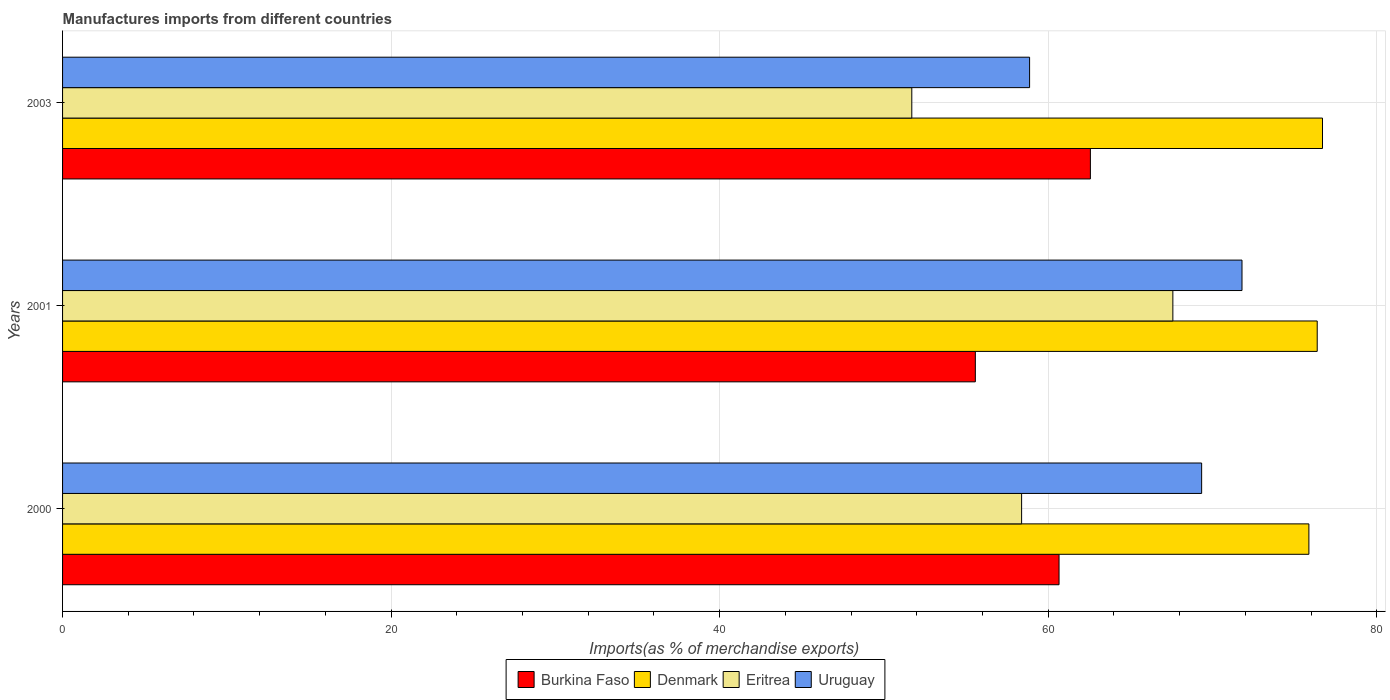How many different coloured bars are there?
Provide a succinct answer. 4. Are the number of bars on each tick of the Y-axis equal?
Ensure brevity in your answer.  Yes. How many bars are there on the 1st tick from the top?
Offer a very short reply. 4. What is the label of the 3rd group of bars from the top?
Your answer should be very brief. 2000. In how many cases, is the number of bars for a given year not equal to the number of legend labels?
Your answer should be very brief. 0. What is the percentage of imports to different countries in Uruguay in 2001?
Ensure brevity in your answer.  71.8. Across all years, what is the maximum percentage of imports to different countries in Uruguay?
Your answer should be very brief. 71.8. Across all years, what is the minimum percentage of imports to different countries in Denmark?
Provide a succinct answer. 75.87. In which year was the percentage of imports to different countries in Denmark minimum?
Your response must be concise. 2000. What is the total percentage of imports to different countries in Eritrea in the graph?
Give a very brief answer. 177.67. What is the difference between the percentage of imports to different countries in Denmark in 2000 and that in 2003?
Ensure brevity in your answer.  -0.83. What is the difference between the percentage of imports to different countries in Burkina Faso in 2000 and the percentage of imports to different countries in Denmark in 2001?
Offer a very short reply. -15.72. What is the average percentage of imports to different countries in Eritrea per year?
Offer a very short reply. 59.22. In the year 2001, what is the difference between the percentage of imports to different countries in Denmark and percentage of imports to different countries in Uruguay?
Ensure brevity in your answer.  4.58. What is the ratio of the percentage of imports to different countries in Uruguay in 2001 to that in 2003?
Your response must be concise. 1.22. Is the percentage of imports to different countries in Eritrea in 2000 less than that in 2001?
Offer a very short reply. Yes. What is the difference between the highest and the second highest percentage of imports to different countries in Denmark?
Give a very brief answer. 0.32. What is the difference between the highest and the lowest percentage of imports to different countries in Uruguay?
Provide a succinct answer. 12.93. Is the sum of the percentage of imports to different countries in Burkina Faso in 2001 and 2003 greater than the maximum percentage of imports to different countries in Uruguay across all years?
Provide a succinct answer. Yes. Is it the case that in every year, the sum of the percentage of imports to different countries in Denmark and percentage of imports to different countries in Eritrea is greater than the sum of percentage of imports to different countries in Uruguay and percentage of imports to different countries in Burkina Faso?
Ensure brevity in your answer.  No. What does the 2nd bar from the bottom in 2003 represents?
Offer a terse response. Denmark. Is it the case that in every year, the sum of the percentage of imports to different countries in Burkina Faso and percentage of imports to different countries in Uruguay is greater than the percentage of imports to different countries in Denmark?
Your response must be concise. Yes. What is the difference between two consecutive major ticks on the X-axis?
Provide a short and direct response. 20. Does the graph contain grids?
Offer a terse response. Yes. Where does the legend appear in the graph?
Offer a terse response. Bottom center. How many legend labels are there?
Offer a terse response. 4. How are the legend labels stacked?
Your answer should be compact. Horizontal. What is the title of the graph?
Provide a short and direct response. Manufactures imports from different countries. Does "Austria" appear as one of the legend labels in the graph?
Your answer should be compact. No. What is the label or title of the X-axis?
Provide a succinct answer. Imports(as % of merchandise exports). What is the Imports(as % of merchandise exports) in Burkina Faso in 2000?
Your answer should be compact. 60.66. What is the Imports(as % of merchandise exports) in Denmark in 2000?
Your answer should be very brief. 75.87. What is the Imports(as % of merchandise exports) of Eritrea in 2000?
Your answer should be compact. 58.38. What is the Imports(as % of merchandise exports) in Uruguay in 2000?
Your answer should be compact. 69.34. What is the Imports(as % of merchandise exports) of Burkina Faso in 2001?
Provide a succinct answer. 55.56. What is the Imports(as % of merchandise exports) in Denmark in 2001?
Your response must be concise. 76.38. What is the Imports(as % of merchandise exports) in Eritrea in 2001?
Offer a terse response. 67.59. What is the Imports(as % of merchandise exports) of Uruguay in 2001?
Keep it short and to the point. 71.8. What is the Imports(as % of merchandise exports) of Burkina Faso in 2003?
Keep it short and to the point. 62.57. What is the Imports(as % of merchandise exports) in Denmark in 2003?
Make the answer very short. 76.7. What is the Imports(as % of merchandise exports) of Eritrea in 2003?
Offer a terse response. 51.7. What is the Imports(as % of merchandise exports) in Uruguay in 2003?
Ensure brevity in your answer.  58.87. Across all years, what is the maximum Imports(as % of merchandise exports) in Burkina Faso?
Make the answer very short. 62.57. Across all years, what is the maximum Imports(as % of merchandise exports) in Denmark?
Make the answer very short. 76.7. Across all years, what is the maximum Imports(as % of merchandise exports) of Eritrea?
Your answer should be very brief. 67.59. Across all years, what is the maximum Imports(as % of merchandise exports) of Uruguay?
Make the answer very short. 71.8. Across all years, what is the minimum Imports(as % of merchandise exports) in Burkina Faso?
Offer a terse response. 55.56. Across all years, what is the minimum Imports(as % of merchandise exports) of Denmark?
Offer a very short reply. 75.87. Across all years, what is the minimum Imports(as % of merchandise exports) of Eritrea?
Ensure brevity in your answer.  51.7. Across all years, what is the minimum Imports(as % of merchandise exports) in Uruguay?
Offer a terse response. 58.87. What is the total Imports(as % of merchandise exports) of Burkina Faso in the graph?
Your response must be concise. 178.79. What is the total Imports(as % of merchandise exports) of Denmark in the graph?
Offer a terse response. 228.94. What is the total Imports(as % of merchandise exports) of Eritrea in the graph?
Keep it short and to the point. 177.67. What is the total Imports(as % of merchandise exports) of Uruguay in the graph?
Make the answer very short. 200. What is the difference between the Imports(as % of merchandise exports) of Burkina Faso in 2000 and that in 2001?
Provide a succinct answer. 5.1. What is the difference between the Imports(as % of merchandise exports) in Denmark in 2000 and that in 2001?
Ensure brevity in your answer.  -0.51. What is the difference between the Imports(as % of merchandise exports) in Eritrea in 2000 and that in 2001?
Your response must be concise. -9.21. What is the difference between the Imports(as % of merchandise exports) of Uruguay in 2000 and that in 2001?
Your answer should be very brief. -2.46. What is the difference between the Imports(as % of merchandise exports) of Burkina Faso in 2000 and that in 2003?
Make the answer very short. -1.91. What is the difference between the Imports(as % of merchandise exports) of Denmark in 2000 and that in 2003?
Offer a very short reply. -0.83. What is the difference between the Imports(as % of merchandise exports) of Eritrea in 2000 and that in 2003?
Provide a short and direct response. 6.68. What is the difference between the Imports(as % of merchandise exports) in Uruguay in 2000 and that in 2003?
Ensure brevity in your answer.  10.47. What is the difference between the Imports(as % of merchandise exports) of Burkina Faso in 2001 and that in 2003?
Offer a terse response. -7. What is the difference between the Imports(as % of merchandise exports) of Denmark in 2001 and that in 2003?
Your answer should be very brief. -0.32. What is the difference between the Imports(as % of merchandise exports) of Eritrea in 2001 and that in 2003?
Offer a terse response. 15.89. What is the difference between the Imports(as % of merchandise exports) in Uruguay in 2001 and that in 2003?
Keep it short and to the point. 12.93. What is the difference between the Imports(as % of merchandise exports) of Burkina Faso in 2000 and the Imports(as % of merchandise exports) of Denmark in 2001?
Your response must be concise. -15.72. What is the difference between the Imports(as % of merchandise exports) of Burkina Faso in 2000 and the Imports(as % of merchandise exports) of Eritrea in 2001?
Make the answer very short. -6.93. What is the difference between the Imports(as % of merchandise exports) in Burkina Faso in 2000 and the Imports(as % of merchandise exports) in Uruguay in 2001?
Your answer should be very brief. -11.14. What is the difference between the Imports(as % of merchandise exports) of Denmark in 2000 and the Imports(as % of merchandise exports) of Eritrea in 2001?
Your response must be concise. 8.28. What is the difference between the Imports(as % of merchandise exports) in Denmark in 2000 and the Imports(as % of merchandise exports) in Uruguay in 2001?
Your answer should be very brief. 4.07. What is the difference between the Imports(as % of merchandise exports) in Eritrea in 2000 and the Imports(as % of merchandise exports) in Uruguay in 2001?
Make the answer very short. -13.42. What is the difference between the Imports(as % of merchandise exports) of Burkina Faso in 2000 and the Imports(as % of merchandise exports) of Denmark in 2003?
Offer a very short reply. -16.04. What is the difference between the Imports(as % of merchandise exports) of Burkina Faso in 2000 and the Imports(as % of merchandise exports) of Eritrea in 2003?
Provide a short and direct response. 8.96. What is the difference between the Imports(as % of merchandise exports) of Burkina Faso in 2000 and the Imports(as % of merchandise exports) of Uruguay in 2003?
Make the answer very short. 1.79. What is the difference between the Imports(as % of merchandise exports) in Denmark in 2000 and the Imports(as % of merchandise exports) in Eritrea in 2003?
Ensure brevity in your answer.  24.17. What is the difference between the Imports(as % of merchandise exports) of Denmark in 2000 and the Imports(as % of merchandise exports) of Uruguay in 2003?
Give a very brief answer. 17. What is the difference between the Imports(as % of merchandise exports) of Eritrea in 2000 and the Imports(as % of merchandise exports) of Uruguay in 2003?
Provide a short and direct response. -0.49. What is the difference between the Imports(as % of merchandise exports) in Burkina Faso in 2001 and the Imports(as % of merchandise exports) in Denmark in 2003?
Give a very brief answer. -21.13. What is the difference between the Imports(as % of merchandise exports) in Burkina Faso in 2001 and the Imports(as % of merchandise exports) in Eritrea in 2003?
Give a very brief answer. 3.87. What is the difference between the Imports(as % of merchandise exports) of Burkina Faso in 2001 and the Imports(as % of merchandise exports) of Uruguay in 2003?
Ensure brevity in your answer.  -3.3. What is the difference between the Imports(as % of merchandise exports) in Denmark in 2001 and the Imports(as % of merchandise exports) in Eritrea in 2003?
Provide a succinct answer. 24.68. What is the difference between the Imports(as % of merchandise exports) of Denmark in 2001 and the Imports(as % of merchandise exports) of Uruguay in 2003?
Make the answer very short. 17.51. What is the difference between the Imports(as % of merchandise exports) of Eritrea in 2001 and the Imports(as % of merchandise exports) of Uruguay in 2003?
Ensure brevity in your answer.  8.72. What is the average Imports(as % of merchandise exports) of Burkina Faso per year?
Your response must be concise. 59.6. What is the average Imports(as % of merchandise exports) in Denmark per year?
Provide a succinct answer. 76.31. What is the average Imports(as % of merchandise exports) of Eritrea per year?
Keep it short and to the point. 59.22. What is the average Imports(as % of merchandise exports) in Uruguay per year?
Your response must be concise. 66.67. In the year 2000, what is the difference between the Imports(as % of merchandise exports) in Burkina Faso and Imports(as % of merchandise exports) in Denmark?
Your response must be concise. -15.21. In the year 2000, what is the difference between the Imports(as % of merchandise exports) in Burkina Faso and Imports(as % of merchandise exports) in Eritrea?
Provide a short and direct response. 2.28. In the year 2000, what is the difference between the Imports(as % of merchandise exports) in Burkina Faso and Imports(as % of merchandise exports) in Uruguay?
Your response must be concise. -8.68. In the year 2000, what is the difference between the Imports(as % of merchandise exports) in Denmark and Imports(as % of merchandise exports) in Eritrea?
Keep it short and to the point. 17.49. In the year 2000, what is the difference between the Imports(as % of merchandise exports) of Denmark and Imports(as % of merchandise exports) of Uruguay?
Your answer should be very brief. 6.53. In the year 2000, what is the difference between the Imports(as % of merchandise exports) in Eritrea and Imports(as % of merchandise exports) in Uruguay?
Provide a succinct answer. -10.96. In the year 2001, what is the difference between the Imports(as % of merchandise exports) in Burkina Faso and Imports(as % of merchandise exports) in Denmark?
Make the answer very short. -20.81. In the year 2001, what is the difference between the Imports(as % of merchandise exports) in Burkina Faso and Imports(as % of merchandise exports) in Eritrea?
Offer a very short reply. -12.02. In the year 2001, what is the difference between the Imports(as % of merchandise exports) in Burkina Faso and Imports(as % of merchandise exports) in Uruguay?
Make the answer very short. -16.23. In the year 2001, what is the difference between the Imports(as % of merchandise exports) in Denmark and Imports(as % of merchandise exports) in Eritrea?
Ensure brevity in your answer.  8.79. In the year 2001, what is the difference between the Imports(as % of merchandise exports) of Denmark and Imports(as % of merchandise exports) of Uruguay?
Make the answer very short. 4.58. In the year 2001, what is the difference between the Imports(as % of merchandise exports) in Eritrea and Imports(as % of merchandise exports) in Uruguay?
Give a very brief answer. -4.21. In the year 2003, what is the difference between the Imports(as % of merchandise exports) of Burkina Faso and Imports(as % of merchandise exports) of Denmark?
Make the answer very short. -14.13. In the year 2003, what is the difference between the Imports(as % of merchandise exports) in Burkina Faso and Imports(as % of merchandise exports) in Eritrea?
Offer a very short reply. 10.87. In the year 2003, what is the difference between the Imports(as % of merchandise exports) in Burkina Faso and Imports(as % of merchandise exports) in Uruguay?
Your answer should be very brief. 3.7. In the year 2003, what is the difference between the Imports(as % of merchandise exports) of Denmark and Imports(as % of merchandise exports) of Eritrea?
Offer a very short reply. 25. In the year 2003, what is the difference between the Imports(as % of merchandise exports) of Denmark and Imports(as % of merchandise exports) of Uruguay?
Your response must be concise. 17.83. In the year 2003, what is the difference between the Imports(as % of merchandise exports) in Eritrea and Imports(as % of merchandise exports) in Uruguay?
Your answer should be very brief. -7.17. What is the ratio of the Imports(as % of merchandise exports) in Burkina Faso in 2000 to that in 2001?
Provide a short and direct response. 1.09. What is the ratio of the Imports(as % of merchandise exports) in Denmark in 2000 to that in 2001?
Offer a very short reply. 0.99. What is the ratio of the Imports(as % of merchandise exports) in Eritrea in 2000 to that in 2001?
Your answer should be compact. 0.86. What is the ratio of the Imports(as % of merchandise exports) of Uruguay in 2000 to that in 2001?
Your answer should be very brief. 0.97. What is the ratio of the Imports(as % of merchandise exports) in Burkina Faso in 2000 to that in 2003?
Your response must be concise. 0.97. What is the ratio of the Imports(as % of merchandise exports) in Denmark in 2000 to that in 2003?
Make the answer very short. 0.99. What is the ratio of the Imports(as % of merchandise exports) of Eritrea in 2000 to that in 2003?
Offer a very short reply. 1.13. What is the ratio of the Imports(as % of merchandise exports) in Uruguay in 2000 to that in 2003?
Your response must be concise. 1.18. What is the ratio of the Imports(as % of merchandise exports) in Burkina Faso in 2001 to that in 2003?
Your answer should be compact. 0.89. What is the ratio of the Imports(as % of merchandise exports) of Denmark in 2001 to that in 2003?
Offer a terse response. 1. What is the ratio of the Imports(as % of merchandise exports) in Eritrea in 2001 to that in 2003?
Provide a succinct answer. 1.31. What is the ratio of the Imports(as % of merchandise exports) in Uruguay in 2001 to that in 2003?
Ensure brevity in your answer.  1.22. What is the difference between the highest and the second highest Imports(as % of merchandise exports) in Burkina Faso?
Your response must be concise. 1.91. What is the difference between the highest and the second highest Imports(as % of merchandise exports) in Denmark?
Offer a very short reply. 0.32. What is the difference between the highest and the second highest Imports(as % of merchandise exports) of Eritrea?
Make the answer very short. 9.21. What is the difference between the highest and the second highest Imports(as % of merchandise exports) in Uruguay?
Offer a very short reply. 2.46. What is the difference between the highest and the lowest Imports(as % of merchandise exports) of Burkina Faso?
Your answer should be very brief. 7. What is the difference between the highest and the lowest Imports(as % of merchandise exports) of Denmark?
Offer a terse response. 0.83. What is the difference between the highest and the lowest Imports(as % of merchandise exports) in Eritrea?
Offer a terse response. 15.89. What is the difference between the highest and the lowest Imports(as % of merchandise exports) of Uruguay?
Keep it short and to the point. 12.93. 